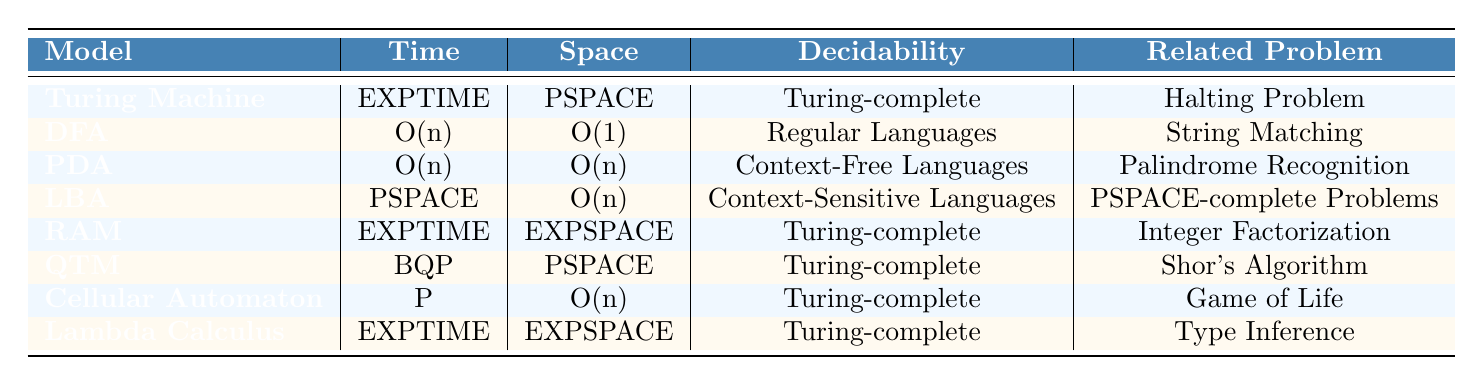What is the time complexity of the Pushdown Automaton? Referring to the table, the time complexity of the Pushdown Automaton is listed as O(n).
Answer: O(n) Which computational model has a space complexity of EXPSPACE? Looking at the table, the Lambda Calculus is the only model with a space complexity of EXPSPACE.
Answer: Lambda Calculus Is the Deterministic Finite Automaton Turing-complete? According to the table, the Deterministic Finite Automaton's decidability is listed as Regular Languages, which indicates it is not Turing-complete.
Answer: No What is the related problem for the Turing Machine? The table states that the related problem for the Turing Machine is the Halting Problem.
Answer: Halting Problem Which models have the same space complexity of O(n)? The Pushdown Automaton and the Cellular Automaton both have a space complexity of O(n) according to the table.
Answer: Pushdown Automaton and Cellular Automaton What is the average time complexity of the models classified as Turing-complete? The models classified as Turing-complete are Turing Machine, Random Access Machine, Quantum Turing Machine, Cellular Automaton, and Lambda Calculus with time complexities EXPTIME, EXPTIME, BQP, P, EXPTIME respectively. Converting these to a numeric scale (assuming BQP is P-complete), we can estimate as follows: EXPTIME (considered as high but set to a value like 1 for average purposes), BQP (also similar as P set to 1), P set to 1, giving an average of (1+1+1+1)/4 = 1.
Answer: 1 Which computational model solves the problem related to Shor's Algorithm? The table indicates that the Quantum Turing Machine is related to Shor's Algorithm.
Answer: Quantum Turing Machine What distinguishes the space complexity of the Random Access Machine from the Linear Bounded Automaton? The Random Access Machine has a space complexity of EXPSPACE, while the Linear Bounded Automaton has a space complexity of O(n), clearly demonstrating that they have different levels of complexity in terms of space usage.
Answer: Different levels of complexity How many models have a time complexity classified as EXPTIME? According to the table, there are three models listed under EXPTIME: Turing Machine, Random Access Machine, and Lambda Calculus.
Answer: 3 Is it true that the Linear Bounded Automaton can recognize context-free languages? The table states that the Linear Bounded Automaton is in fact capable of recognizing context-sensitive languages. Therefore, it does not recognize context-free languages directly.
Answer: No What is the time complexity of a model that can decide context-free languages? The Pushdown Automaton can decide context-free languages, and its time complexity according to the table is O(n).
Answer: O(n) 